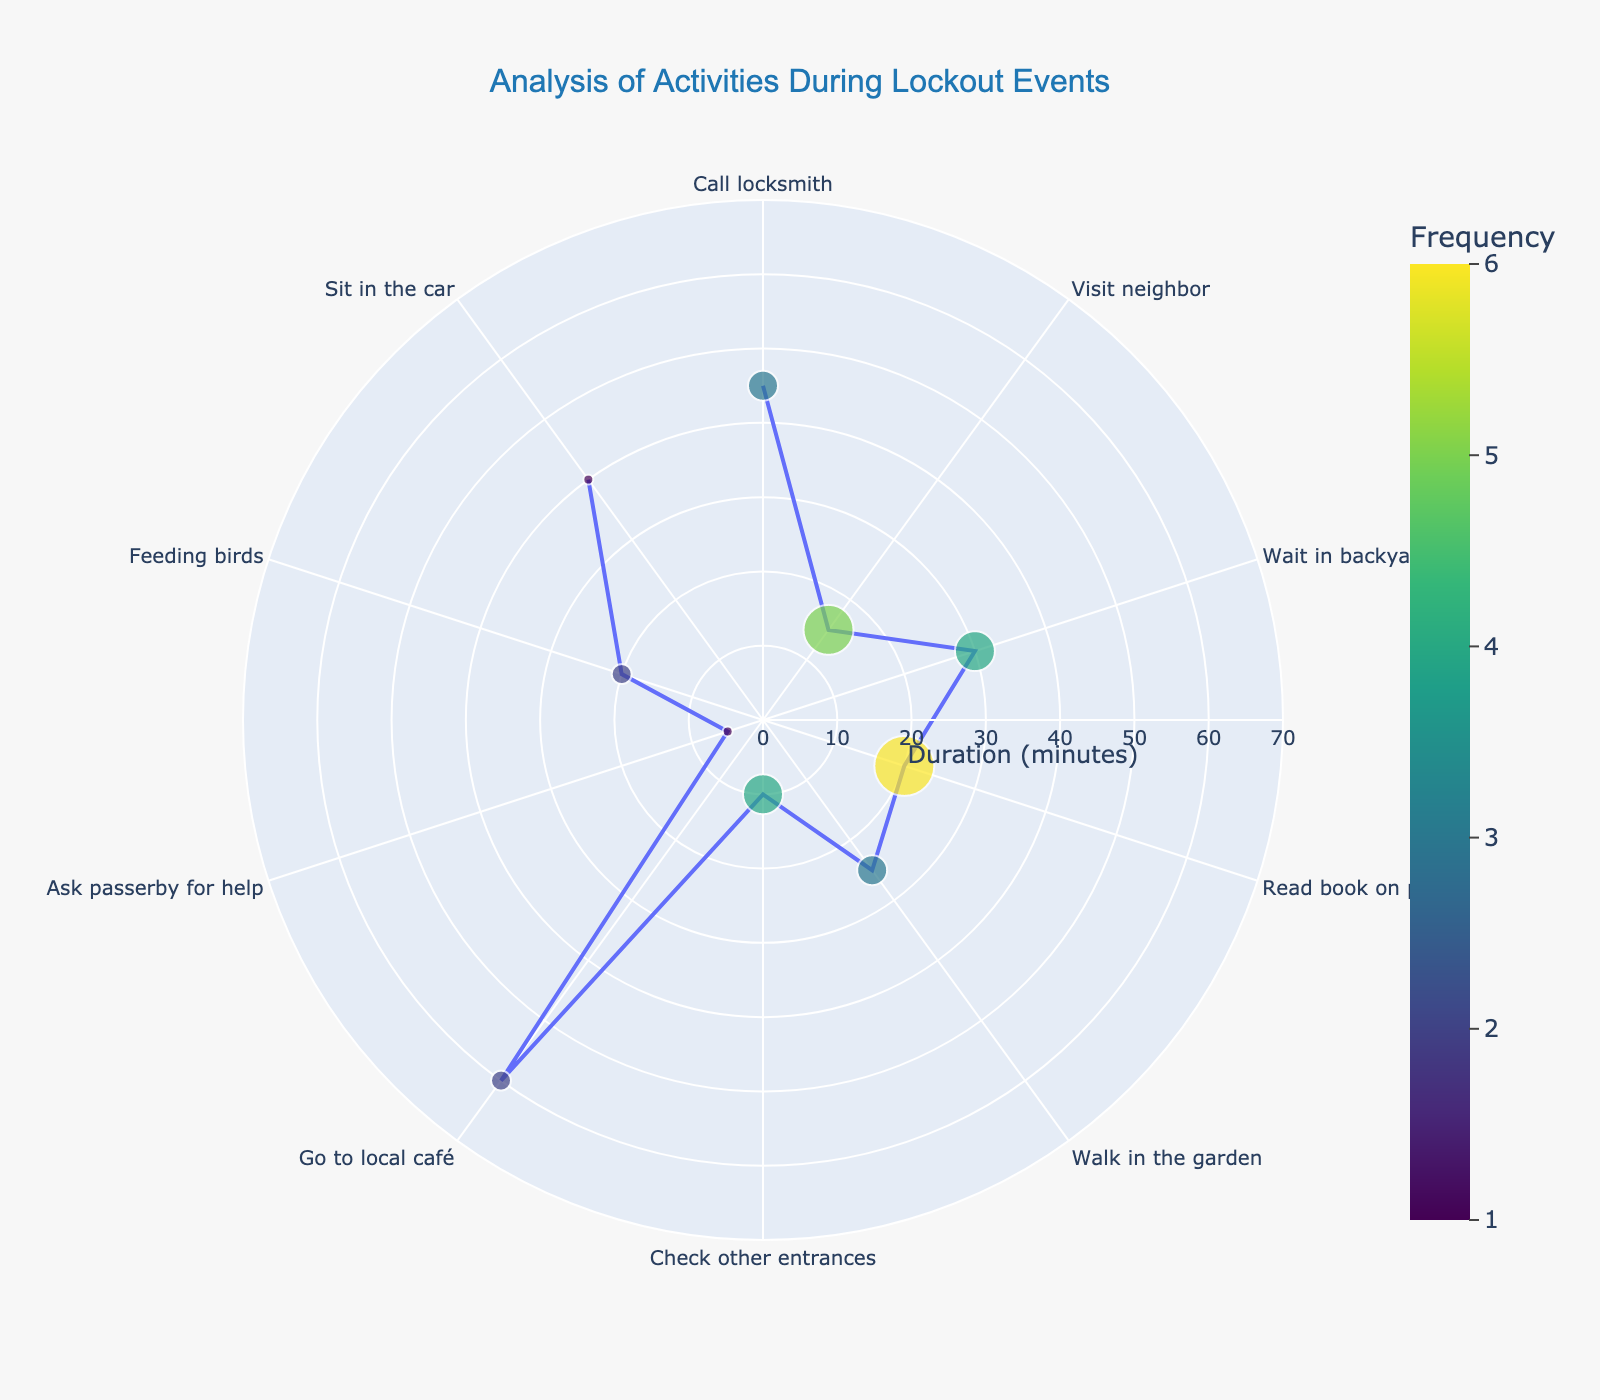What is the title of the plot? The title is written at the top of the figure and summarizes the content of the visual, indicating it is related to activities during lockout events.
Answer: "Analysis of Activities During Lockout Events" Which activity has the highest frequency? By looking at the color scale and the size of the markers, the activity with the largest marker and darkest color has the highest frequency. "Read book on porch" has the largest marker with frequency 6.
Answer: "Read book on porch" How long, on average, do activities last during lockout events? To find the average duration, sum up all the durations of each activity and then divide by the number of activities. The total duration is 270 minutes (45 + 15 + 30 + 20 + 25 + 10 + 60 + 5 + 20 + 40). There are 10 activities, so the average duration is 270/10.
Answer: 27 minutes Which activities take the shortest and longest durations? The radial distance (length from the center) represents duration in the plot. The shortest duration corresponds to the smallest radial distance, and the longest duration corresponds to the largest radial distance. "Ask passerby for help" is 5 minutes, and "Go to local café" is 60 minutes.
Answer: "Ask passerby for help" and "Go to local café" How does the frequency of "Visit neighbor" compare to "Check other entrances"? By comparing the marker sizes and colors, we can see that "Visit neighbor" has a frequency of 5 and "Check other entrances" has a frequency of 4.
Answer: "Visit neighbor" has a higher frequency What's the combined frequency of all activities that involve staying at home? Activities that involve staying at home are "Visit neighbor," "Wait in backyard," "Read book on porch," "Walk in the garden," "Check other entrances," "Feeding birds," and "Sit in the car." Adding their frequencies: 5 + 4 + 6 + 3 + 4 + 2 + 1 = 25.
Answer: 25 If you have 1 hour to spend, which activities can you do entirely? One hour equals 60 minutes. We look for activities that have durations less than or equal to 60 minutes. "Call locksmith" (45), "Visit neighbor" (15), "Wait in backyard" (30), "Read book on porch" (20), "Walk in the garden" (25), "Check other entrances" (10), "Ask passerby for help" (5), "Feeding birds" (20), and "Sit in the car" (40).
Answer: 9 activities What is the most common duration for activities? This question requires looking at which duration appears most frequently in the radial axis. The durations and their frequencies are: 45 (1), 15 (1), 30 (1), 20 (2), 25 (1), 10 (1), 60 (1), 5 (1), 40 (1). The duration of 20 minutes appears twice.
Answer: 20 minutes How does the size of the marker relate to frequency? The marker size is proportional to the frequency. According to the data, the size is calculated using the frequency multiplied by 5. Higher frequency results in larger markers.
Answer: Larger markers indicate higher frequency How many activities have a duration of over 30 minutes? Checking the radial distance (duration) for activities greater than 30 minutes, we have "Call locksmith" (45), "Go to local café" (60), "Sit in the car" (40). This makes a total of 3 activities.
Answer: 3 